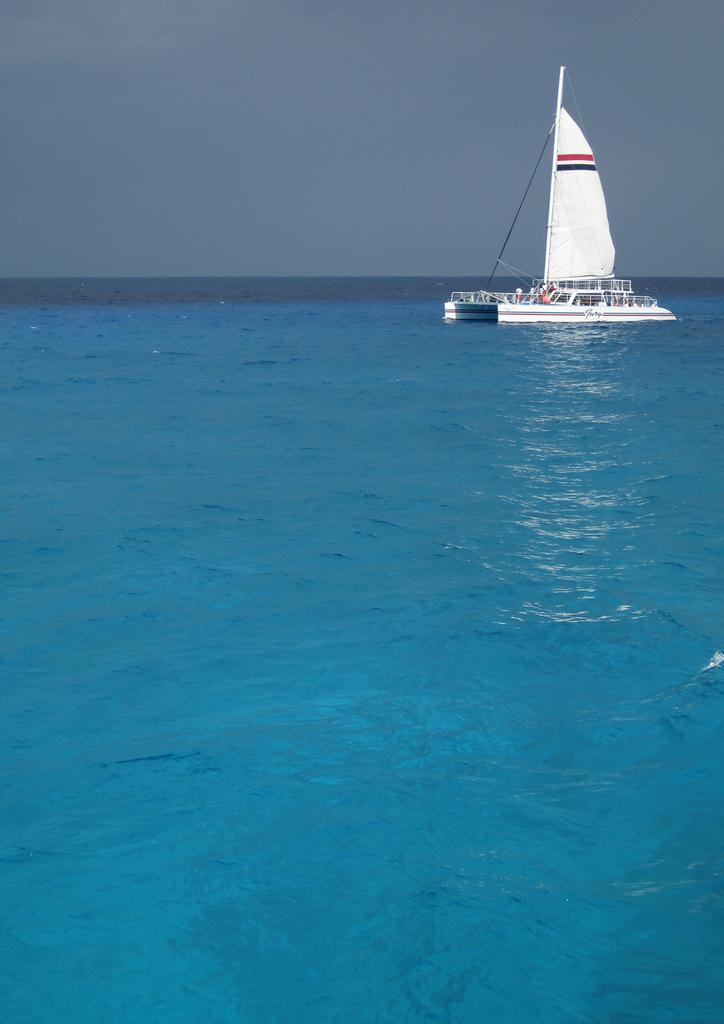What is the main subject of the image? The main subject of the image is a boat. Where is the boat located? The boat is on the water. What can be seen in the background of the image? There is sky visible in the background of the image. How many cars are parked near the window in the image? There are no cars or windows present in the image; it features a boat on the water with sky visible in the background. 